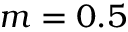Convert formula to latex. <formula><loc_0><loc_0><loc_500><loc_500>m = 0 . 5</formula> 